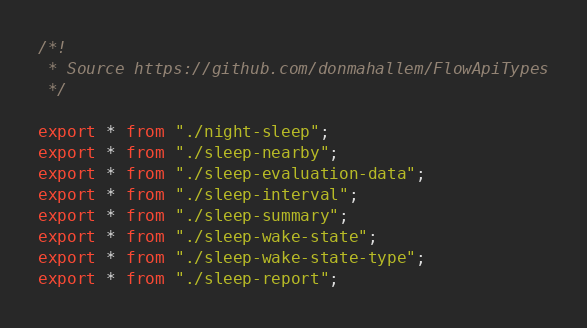<code> <loc_0><loc_0><loc_500><loc_500><_TypeScript_>/*!
 * Source https://github.com/donmahallem/FlowApiTypes
 */

export * from "./night-sleep";
export * from "./sleep-nearby";
export * from "./sleep-evaluation-data";
export * from "./sleep-interval";
export * from "./sleep-summary";
export * from "./sleep-wake-state";
export * from "./sleep-wake-state-type";
export * from "./sleep-report";</code> 